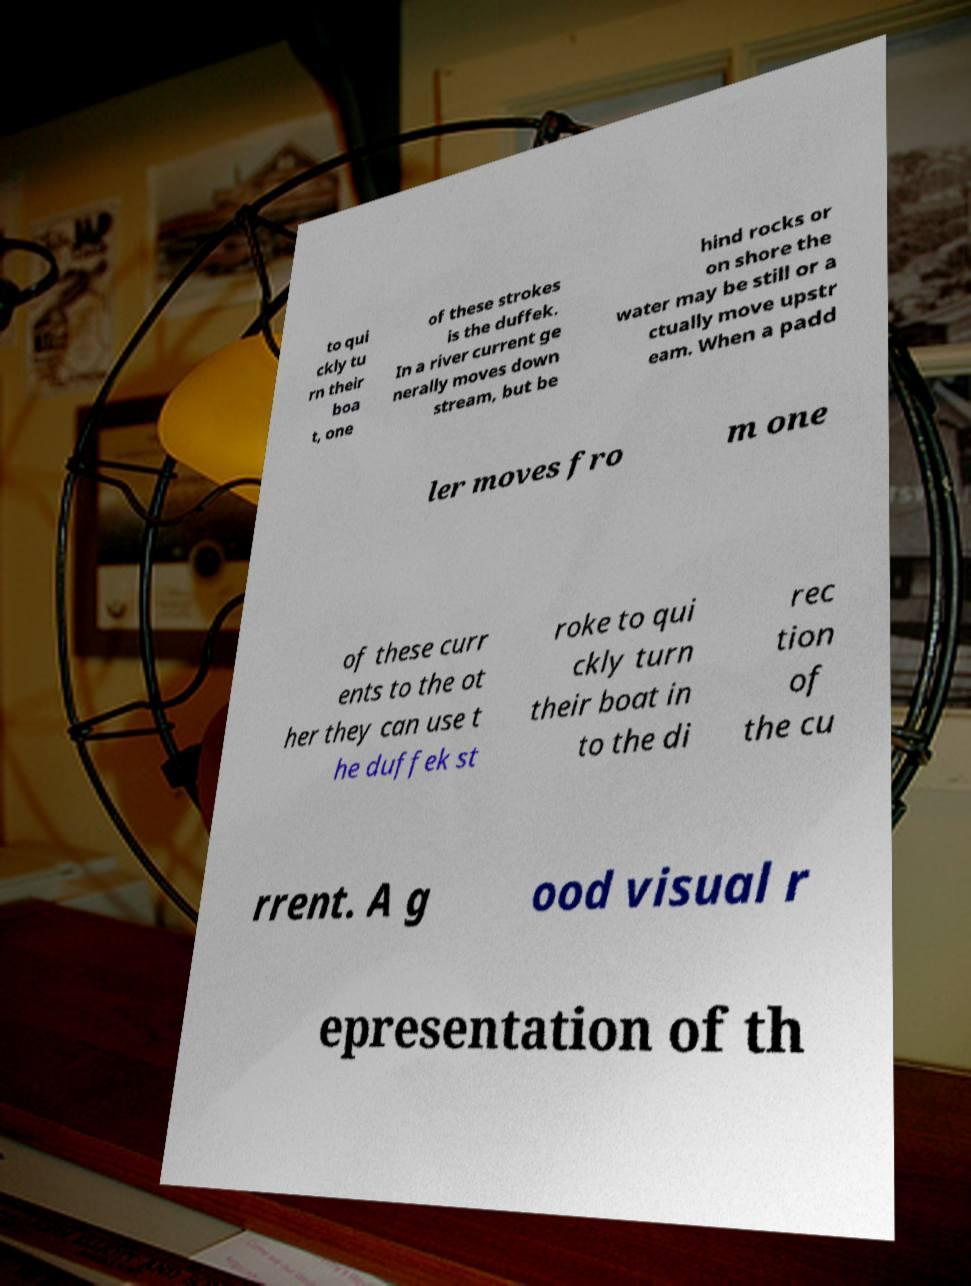Can you read and provide the text displayed in the image?This photo seems to have some interesting text. Can you extract and type it out for me? to qui ckly tu rn their boa t, one of these strokes is the duffek. In a river current ge nerally moves down stream, but be hind rocks or on shore the water may be still or a ctually move upstr eam. When a padd ler moves fro m one of these curr ents to the ot her they can use t he duffek st roke to qui ckly turn their boat in to the di rec tion of the cu rrent. A g ood visual r epresentation of th 